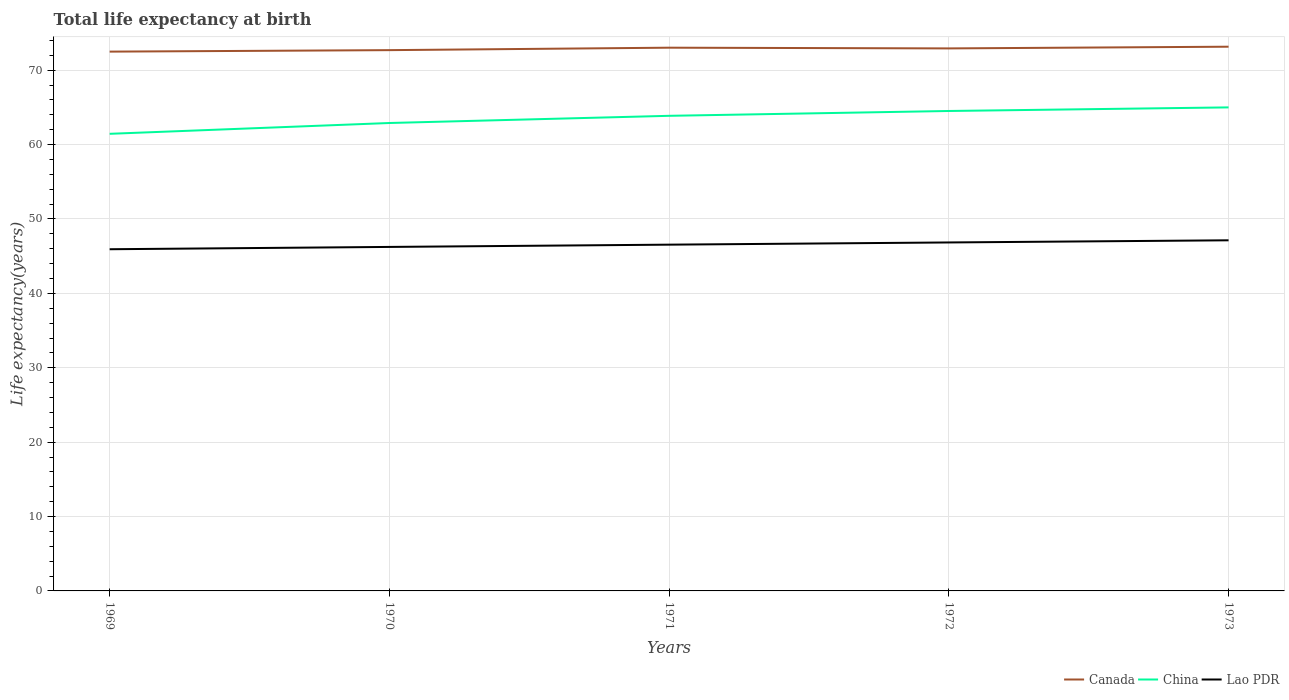How many different coloured lines are there?
Provide a succinct answer. 3. Across all years, what is the maximum life expectancy at birth in in Lao PDR?
Provide a short and direct response. 45.94. In which year was the life expectancy at birth in in China maximum?
Your response must be concise. 1969. What is the total life expectancy at birth in in China in the graph?
Your answer should be very brief. -3.55. What is the difference between the highest and the second highest life expectancy at birth in in China?
Your response must be concise. 3.55. Is the life expectancy at birth in in China strictly greater than the life expectancy at birth in in Lao PDR over the years?
Offer a terse response. No. How many years are there in the graph?
Provide a succinct answer. 5. What is the difference between two consecutive major ticks on the Y-axis?
Keep it short and to the point. 10. Are the values on the major ticks of Y-axis written in scientific E-notation?
Ensure brevity in your answer.  No. Does the graph contain grids?
Offer a terse response. Yes. How are the legend labels stacked?
Your answer should be very brief. Horizontal. What is the title of the graph?
Provide a succinct answer. Total life expectancy at birth. Does "High income: OECD" appear as one of the legend labels in the graph?
Keep it short and to the point. No. What is the label or title of the Y-axis?
Offer a terse response. Life expectancy(years). What is the Life expectancy(years) in Canada in 1969?
Ensure brevity in your answer.  72.5. What is the Life expectancy(years) of China in 1969?
Offer a terse response. 61.45. What is the Life expectancy(years) in Lao PDR in 1969?
Keep it short and to the point. 45.94. What is the Life expectancy(years) of Canada in 1970?
Keep it short and to the point. 72.7. What is the Life expectancy(years) of China in 1970?
Offer a very short reply. 62.91. What is the Life expectancy(years) in Lao PDR in 1970?
Your answer should be very brief. 46.24. What is the Life expectancy(years) of Canada in 1971?
Offer a very short reply. 73.03. What is the Life expectancy(years) in China in 1971?
Provide a succinct answer. 63.87. What is the Life expectancy(years) in Lao PDR in 1971?
Provide a succinct answer. 46.55. What is the Life expectancy(years) in Canada in 1972?
Provide a short and direct response. 72.93. What is the Life expectancy(years) in China in 1972?
Give a very brief answer. 64.52. What is the Life expectancy(years) of Lao PDR in 1972?
Provide a succinct answer. 46.85. What is the Life expectancy(years) of Canada in 1973?
Your answer should be very brief. 73.16. What is the Life expectancy(years) in China in 1973?
Offer a terse response. 65. What is the Life expectancy(years) of Lao PDR in 1973?
Your answer should be compact. 47.14. Across all years, what is the maximum Life expectancy(years) in Canada?
Your answer should be compact. 73.16. Across all years, what is the maximum Life expectancy(years) in China?
Offer a terse response. 65. Across all years, what is the maximum Life expectancy(years) in Lao PDR?
Ensure brevity in your answer.  47.14. Across all years, what is the minimum Life expectancy(years) of Canada?
Offer a very short reply. 72.5. Across all years, what is the minimum Life expectancy(years) of China?
Provide a succinct answer. 61.45. Across all years, what is the minimum Life expectancy(years) in Lao PDR?
Your answer should be very brief. 45.94. What is the total Life expectancy(years) of Canada in the graph?
Offer a terse response. 364.33. What is the total Life expectancy(years) of China in the graph?
Offer a terse response. 317.75. What is the total Life expectancy(years) in Lao PDR in the graph?
Offer a very short reply. 232.71. What is the difference between the Life expectancy(years) in Canada in 1969 and that in 1970?
Keep it short and to the point. -0.2. What is the difference between the Life expectancy(years) of China in 1969 and that in 1970?
Ensure brevity in your answer.  -1.46. What is the difference between the Life expectancy(years) of Lao PDR in 1969 and that in 1970?
Ensure brevity in your answer.  -0.31. What is the difference between the Life expectancy(years) of Canada in 1969 and that in 1971?
Provide a succinct answer. -0.53. What is the difference between the Life expectancy(years) in China in 1969 and that in 1971?
Offer a very short reply. -2.42. What is the difference between the Life expectancy(years) of Lao PDR in 1969 and that in 1971?
Offer a terse response. -0.61. What is the difference between the Life expectancy(years) of Canada in 1969 and that in 1972?
Offer a terse response. -0.43. What is the difference between the Life expectancy(years) in China in 1969 and that in 1972?
Your response must be concise. -3.07. What is the difference between the Life expectancy(years) of Lao PDR in 1969 and that in 1972?
Keep it short and to the point. -0.91. What is the difference between the Life expectancy(years) of Canada in 1969 and that in 1973?
Make the answer very short. -0.66. What is the difference between the Life expectancy(years) in China in 1969 and that in 1973?
Keep it short and to the point. -3.55. What is the difference between the Life expectancy(years) in Lao PDR in 1969 and that in 1973?
Offer a terse response. -1.2. What is the difference between the Life expectancy(years) of Canada in 1970 and that in 1971?
Your answer should be very brief. -0.33. What is the difference between the Life expectancy(years) of China in 1970 and that in 1971?
Offer a very short reply. -0.97. What is the difference between the Life expectancy(years) in Lao PDR in 1970 and that in 1971?
Provide a short and direct response. -0.3. What is the difference between the Life expectancy(years) in Canada in 1970 and that in 1972?
Your response must be concise. -0.23. What is the difference between the Life expectancy(years) in China in 1970 and that in 1972?
Keep it short and to the point. -1.62. What is the difference between the Life expectancy(years) in Lao PDR in 1970 and that in 1972?
Provide a succinct answer. -0.6. What is the difference between the Life expectancy(years) of Canada in 1970 and that in 1973?
Provide a succinct answer. -0.46. What is the difference between the Life expectancy(years) of China in 1970 and that in 1973?
Your response must be concise. -2.1. What is the difference between the Life expectancy(years) of Lao PDR in 1970 and that in 1973?
Make the answer very short. -0.89. What is the difference between the Life expectancy(years) in Canada in 1971 and that in 1972?
Make the answer very short. 0.1. What is the difference between the Life expectancy(years) in China in 1971 and that in 1972?
Give a very brief answer. -0.65. What is the difference between the Life expectancy(years) in Lao PDR in 1971 and that in 1972?
Your answer should be very brief. -0.3. What is the difference between the Life expectancy(years) of Canada in 1971 and that in 1973?
Offer a terse response. -0.13. What is the difference between the Life expectancy(years) in China in 1971 and that in 1973?
Make the answer very short. -1.13. What is the difference between the Life expectancy(years) of Lao PDR in 1971 and that in 1973?
Provide a succinct answer. -0.59. What is the difference between the Life expectancy(years) of Canada in 1972 and that in 1973?
Provide a short and direct response. -0.23. What is the difference between the Life expectancy(years) of China in 1972 and that in 1973?
Your answer should be very brief. -0.48. What is the difference between the Life expectancy(years) of Lao PDR in 1972 and that in 1973?
Give a very brief answer. -0.29. What is the difference between the Life expectancy(years) of Canada in 1969 and the Life expectancy(years) of China in 1970?
Offer a terse response. 9.6. What is the difference between the Life expectancy(years) of Canada in 1969 and the Life expectancy(years) of Lao PDR in 1970?
Your response must be concise. 26.26. What is the difference between the Life expectancy(years) in China in 1969 and the Life expectancy(years) in Lao PDR in 1970?
Ensure brevity in your answer.  15.21. What is the difference between the Life expectancy(years) in Canada in 1969 and the Life expectancy(years) in China in 1971?
Offer a very short reply. 8.63. What is the difference between the Life expectancy(years) in Canada in 1969 and the Life expectancy(years) in Lao PDR in 1971?
Keep it short and to the point. 25.95. What is the difference between the Life expectancy(years) in China in 1969 and the Life expectancy(years) in Lao PDR in 1971?
Provide a short and direct response. 14.9. What is the difference between the Life expectancy(years) in Canada in 1969 and the Life expectancy(years) in China in 1972?
Provide a succinct answer. 7.98. What is the difference between the Life expectancy(years) in Canada in 1969 and the Life expectancy(years) in Lao PDR in 1972?
Give a very brief answer. 25.65. What is the difference between the Life expectancy(years) of China in 1969 and the Life expectancy(years) of Lao PDR in 1972?
Give a very brief answer. 14.6. What is the difference between the Life expectancy(years) in Canada in 1969 and the Life expectancy(years) in China in 1973?
Keep it short and to the point. 7.5. What is the difference between the Life expectancy(years) in Canada in 1969 and the Life expectancy(years) in Lao PDR in 1973?
Keep it short and to the point. 25.37. What is the difference between the Life expectancy(years) of China in 1969 and the Life expectancy(years) of Lao PDR in 1973?
Your answer should be very brief. 14.32. What is the difference between the Life expectancy(years) in Canada in 1970 and the Life expectancy(years) in China in 1971?
Your response must be concise. 8.83. What is the difference between the Life expectancy(years) in Canada in 1970 and the Life expectancy(years) in Lao PDR in 1971?
Make the answer very short. 26.15. What is the difference between the Life expectancy(years) of China in 1970 and the Life expectancy(years) of Lao PDR in 1971?
Your answer should be very brief. 16.36. What is the difference between the Life expectancy(years) in Canada in 1970 and the Life expectancy(years) in China in 1972?
Provide a short and direct response. 8.18. What is the difference between the Life expectancy(years) in Canada in 1970 and the Life expectancy(years) in Lao PDR in 1972?
Offer a terse response. 25.85. What is the difference between the Life expectancy(years) of China in 1970 and the Life expectancy(years) of Lao PDR in 1972?
Provide a succinct answer. 16.06. What is the difference between the Life expectancy(years) in Canada in 1970 and the Life expectancy(years) in China in 1973?
Your response must be concise. 7.7. What is the difference between the Life expectancy(years) of Canada in 1970 and the Life expectancy(years) of Lao PDR in 1973?
Provide a succinct answer. 25.56. What is the difference between the Life expectancy(years) of China in 1970 and the Life expectancy(years) of Lao PDR in 1973?
Make the answer very short. 15.77. What is the difference between the Life expectancy(years) in Canada in 1971 and the Life expectancy(years) in China in 1972?
Give a very brief answer. 8.51. What is the difference between the Life expectancy(years) in Canada in 1971 and the Life expectancy(years) in Lao PDR in 1972?
Offer a terse response. 26.18. What is the difference between the Life expectancy(years) of China in 1971 and the Life expectancy(years) of Lao PDR in 1972?
Your answer should be very brief. 17.03. What is the difference between the Life expectancy(years) of Canada in 1971 and the Life expectancy(years) of China in 1973?
Ensure brevity in your answer.  8.03. What is the difference between the Life expectancy(years) of Canada in 1971 and the Life expectancy(years) of Lao PDR in 1973?
Your response must be concise. 25.89. What is the difference between the Life expectancy(years) of China in 1971 and the Life expectancy(years) of Lao PDR in 1973?
Offer a terse response. 16.74. What is the difference between the Life expectancy(years) of Canada in 1972 and the Life expectancy(years) of China in 1973?
Give a very brief answer. 7.93. What is the difference between the Life expectancy(years) in Canada in 1972 and the Life expectancy(years) in Lao PDR in 1973?
Keep it short and to the point. 25.8. What is the difference between the Life expectancy(years) of China in 1972 and the Life expectancy(years) of Lao PDR in 1973?
Provide a succinct answer. 17.39. What is the average Life expectancy(years) in Canada per year?
Your response must be concise. 72.87. What is the average Life expectancy(years) in China per year?
Offer a very short reply. 63.55. What is the average Life expectancy(years) in Lao PDR per year?
Provide a short and direct response. 46.54. In the year 1969, what is the difference between the Life expectancy(years) in Canada and Life expectancy(years) in China?
Make the answer very short. 11.05. In the year 1969, what is the difference between the Life expectancy(years) in Canada and Life expectancy(years) in Lao PDR?
Ensure brevity in your answer.  26.57. In the year 1969, what is the difference between the Life expectancy(years) in China and Life expectancy(years) in Lao PDR?
Your response must be concise. 15.52. In the year 1970, what is the difference between the Life expectancy(years) in Canada and Life expectancy(years) in China?
Offer a very short reply. 9.79. In the year 1970, what is the difference between the Life expectancy(years) in Canada and Life expectancy(years) in Lao PDR?
Ensure brevity in your answer.  26.46. In the year 1970, what is the difference between the Life expectancy(years) of China and Life expectancy(years) of Lao PDR?
Ensure brevity in your answer.  16.66. In the year 1971, what is the difference between the Life expectancy(years) in Canada and Life expectancy(years) in China?
Keep it short and to the point. 9.16. In the year 1971, what is the difference between the Life expectancy(years) of Canada and Life expectancy(years) of Lao PDR?
Your answer should be compact. 26.48. In the year 1971, what is the difference between the Life expectancy(years) of China and Life expectancy(years) of Lao PDR?
Make the answer very short. 17.32. In the year 1972, what is the difference between the Life expectancy(years) of Canada and Life expectancy(years) of China?
Offer a very short reply. 8.41. In the year 1972, what is the difference between the Life expectancy(years) in Canada and Life expectancy(years) in Lao PDR?
Give a very brief answer. 26.09. In the year 1972, what is the difference between the Life expectancy(years) in China and Life expectancy(years) in Lao PDR?
Your answer should be very brief. 17.67. In the year 1973, what is the difference between the Life expectancy(years) in Canada and Life expectancy(years) in China?
Make the answer very short. 8.16. In the year 1973, what is the difference between the Life expectancy(years) in Canada and Life expectancy(years) in Lao PDR?
Your response must be concise. 26.03. In the year 1973, what is the difference between the Life expectancy(years) in China and Life expectancy(years) in Lao PDR?
Offer a terse response. 17.87. What is the ratio of the Life expectancy(years) of China in 1969 to that in 1970?
Provide a succinct answer. 0.98. What is the ratio of the Life expectancy(years) of Canada in 1969 to that in 1971?
Make the answer very short. 0.99. What is the ratio of the Life expectancy(years) of China in 1969 to that in 1971?
Your answer should be very brief. 0.96. What is the ratio of the Life expectancy(years) of Canada in 1969 to that in 1972?
Your response must be concise. 0.99. What is the ratio of the Life expectancy(years) in China in 1969 to that in 1972?
Your answer should be compact. 0.95. What is the ratio of the Life expectancy(years) in Lao PDR in 1969 to that in 1972?
Offer a terse response. 0.98. What is the ratio of the Life expectancy(years) of China in 1969 to that in 1973?
Offer a very short reply. 0.95. What is the ratio of the Life expectancy(years) of Lao PDR in 1969 to that in 1973?
Offer a very short reply. 0.97. What is the ratio of the Life expectancy(years) in China in 1970 to that in 1971?
Your answer should be very brief. 0.98. What is the ratio of the Life expectancy(years) of Lao PDR in 1970 to that in 1971?
Offer a very short reply. 0.99. What is the ratio of the Life expectancy(years) of Canada in 1970 to that in 1972?
Ensure brevity in your answer.  1. What is the ratio of the Life expectancy(years) of China in 1970 to that in 1972?
Give a very brief answer. 0.97. What is the ratio of the Life expectancy(years) in Lao PDR in 1970 to that in 1972?
Keep it short and to the point. 0.99. What is the ratio of the Life expectancy(years) in Lao PDR in 1970 to that in 1973?
Your response must be concise. 0.98. What is the ratio of the Life expectancy(years) in China in 1971 to that in 1972?
Offer a terse response. 0.99. What is the ratio of the Life expectancy(years) of China in 1971 to that in 1973?
Ensure brevity in your answer.  0.98. What is the ratio of the Life expectancy(years) of Lao PDR in 1971 to that in 1973?
Provide a short and direct response. 0.99. What is the ratio of the Life expectancy(years) of China in 1972 to that in 1973?
Offer a terse response. 0.99. What is the ratio of the Life expectancy(years) of Lao PDR in 1972 to that in 1973?
Your answer should be compact. 0.99. What is the difference between the highest and the second highest Life expectancy(years) in Canada?
Provide a short and direct response. 0.13. What is the difference between the highest and the second highest Life expectancy(years) in China?
Offer a very short reply. 0.48. What is the difference between the highest and the second highest Life expectancy(years) in Lao PDR?
Your response must be concise. 0.29. What is the difference between the highest and the lowest Life expectancy(years) in Canada?
Give a very brief answer. 0.66. What is the difference between the highest and the lowest Life expectancy(years) in China?
Your answer should be compact. 3.55. What is the difference between the highest and the lowest Life expectancy(years) in Lao PDR?
Give a very brief answer. 1.2. 